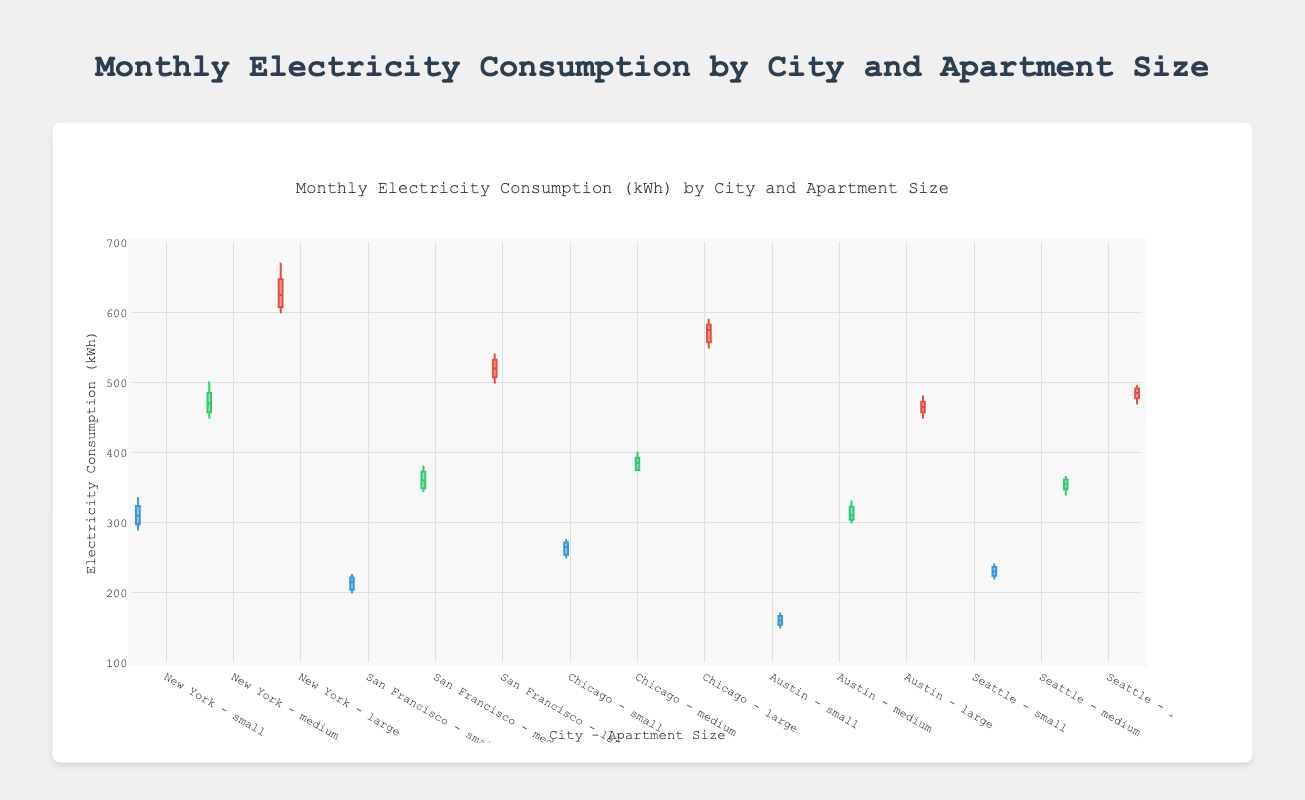What is the title of the figure? The title is usually located at the top center of the figure. From the given code, the title is "Monthly Electricity Consumption (kWh) by City and Apartment Size".
Answer: Monthly Electricity Consumption (kWh) by City and Apartment Size What is the y-axis title? The y-axis title is specified in the layout of the figure as "Electricity Consumption (kWh)". This title indicates what kind of data is being plotted against the y-axis.
Answer: Electricity Consumption (kWh) Which city has the highest median monthly electricity consumption for large apartments? By observing the box plot, each city and apartment size will have its median marked by a horizontal line inside the box. The highest median for large apartments is found by comparing these medians across all cities.
Answer: New York Which city's small apartments have the lowest range of monthly electricity consumption values? The range can be found by looking at the distance between the bottom and top whiskers of the box plot. The city with the smallest distance between these whiskers for small apartments has the lowest range.
Answer: Austin How does the median electricity consumption for medium-sized apartments in San Francisco compare to New York? Locate the median lines (inside the boxes) for medium-sized apartments in both San Francisco and New York. Compare their positions to see which is higher. New York's median for medium-sized apartments is higher.
Answer: New York is higher What is the interquartile range (IQR) for large apartments in Chicago? The IQR is the range between the first quartile (Q1) and third quartile (Q3) within the box. Identify the bottom and top of the box for Chicago's large apartments and calculate Q3 - Q1.
Answer: 20 Which city has the most consistent (least variability) electricity consumption for medium-sized apartments? Consistency or variability can be assessed by the length of the box and whiskers. The smaller the length, the more consistent the data.
Answer: Austin What is the difference between the maximum value of electricity consumption for small apartments in New York and San Francisco? Maximum values are typically indicated by the topmost points (whiskers or outliers). Identify these points for small apartments in both cities and subtract San Francisco's maximum from New York's maximum.
Answer: 110 Between Chicago and Seattle, which city has a larger spread of monthly electricity consumption values for large apartments? The spread is determined by the distance between the first quartile (Q1) and third quartile (Q3). Compare these distances on the box plots for each city’s large apartments.
Answer: Chicago What is the main visual difference between the electricity consumption data for small apartments in Austin and Seattle? Observe the box plots for small apartments in both cities. Look for differences in the placement of median lines, the range between quartiles (box length), and the whisker lengths.
Answer: Austin has lower values 